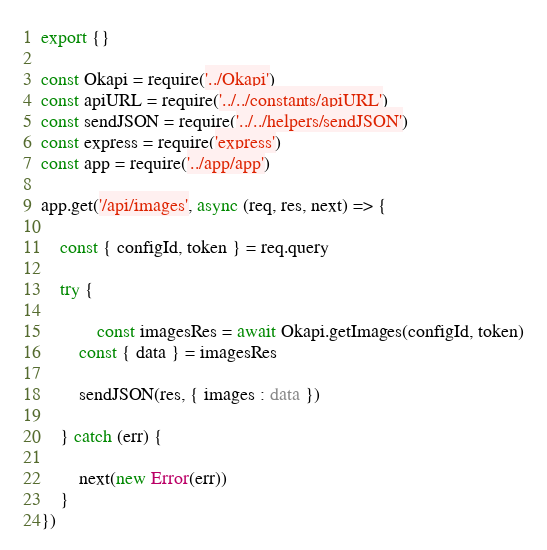Convert code to text. <code><loc_0><loc_0><loc_500><loc_500><_TypeScript_>export {}

const Okapi = require('../Okapi')
const apiURL = require('../../constants/apiURL')
const sendJSON = require('../../helpers/sendJSON')
const express = require('express')
const app = require('../app/app')

app.get('/api/images', async (req, res, next) => {

	const { configId, token } = req.query

	try {

	        const imagesRes = await Okapi.getImages(configId, token)
		const { data } = imagesRes

		sendJSON(res, { images : data })

	} catch (err) {
		
		next(new Error(err))
	}
})
</code> 